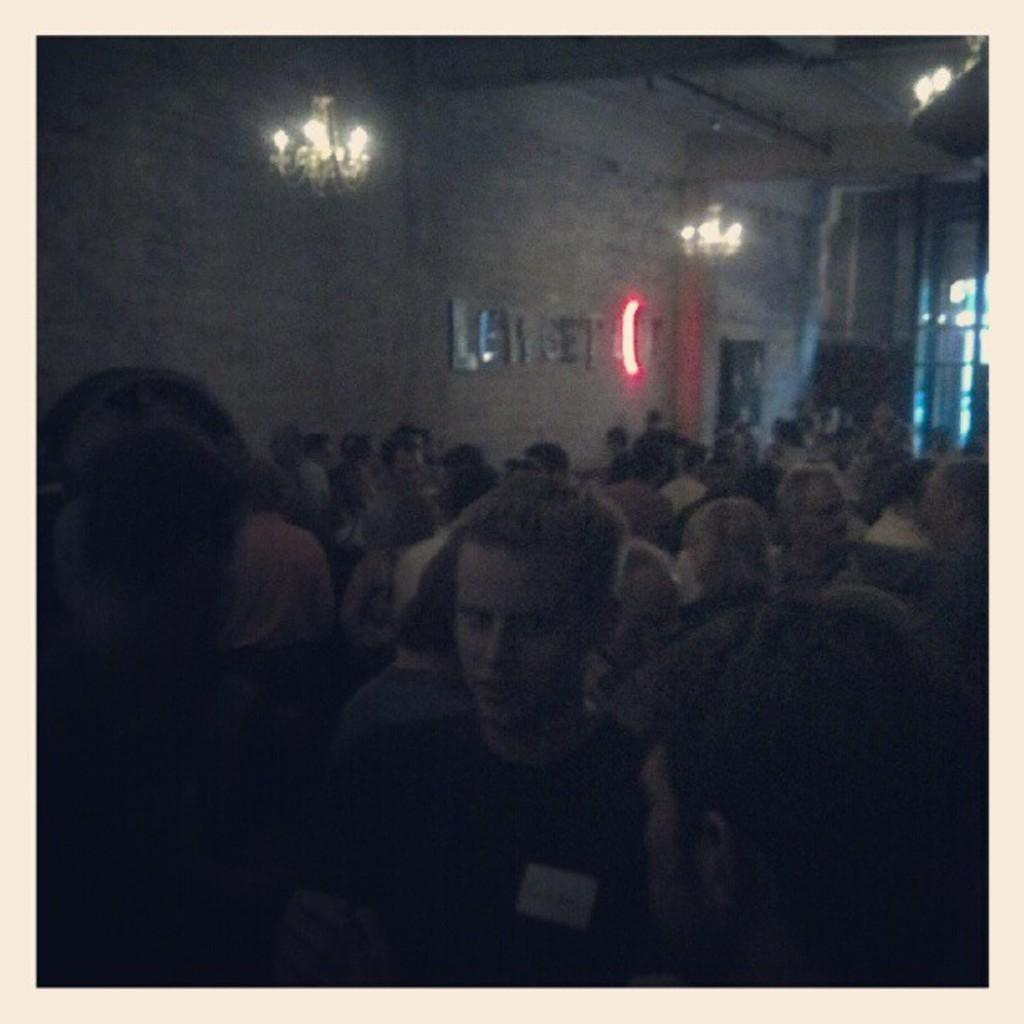What is the main subject of the image? The main subject of the image is a group of people. What can be seen in the background of the image? There are lights and a wall in the background of the image. What type of calendar is hanging on the wall in the image? There is no calendar visible in the image; only lights and a wall are present in the background. 